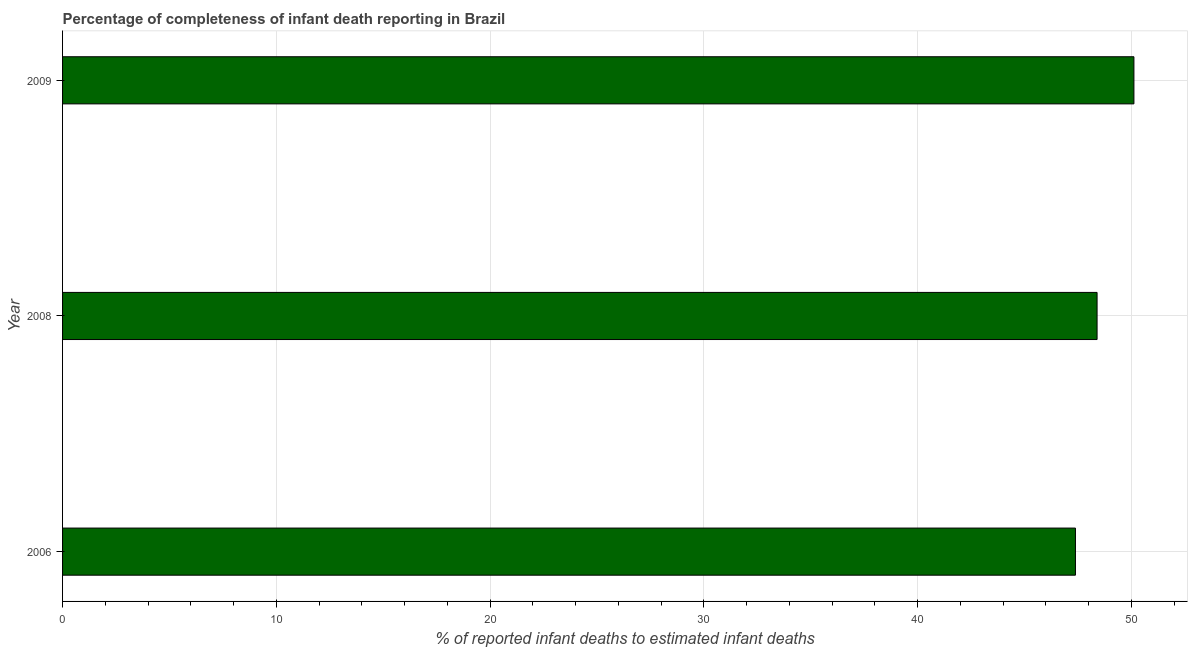What is the title of the graph?
Give a very brief answer. Percentage of completeness of infant death reporting in Brazil. What is the label or title of the X-axis?
Keep it short and to the point. % of reported infant deaths to estimated infant deaths. What is the label or title of the Y-axis?
Offer a very short reply. Year. What is the completeness of infant death reporting in 2009?
Keep it short and to the point. 50.12. Across all years, what is the maximum completeness of infant death reporting?
Provide a short and direct response. 50.12. Across all years, what is the minimum completeness of infant death reporting?
Your answer should be very brief. 47.38. What is the sum of the completeness of infant death reporting?
Make the answer very short. 145.89. What is the difference between the completeness of infant death reporting in 2008 and 2009?
Offer a terse response. -1.72. What is the average completeness of infant death reporting per year?
Offer a terse response. 48.63. What is the median completeness of infant death reporting?
Provide a succinct answer. 48.39. In how many years, is the completeness of infant death reporting greater than 16 %?
Ensure brevity in your answer.  3. Do a majority of the years between 2009 and 2006 (inclusive) have completeness of infant death reporting greater than 40 %?
Ensure brevity in your answer.  Yes. What is the ratio of the completeness of infant death reporting in 2008 to that in 2009?
Give a very brief answer. 0.97. Is the completeness of infant death reporting in 2006 less than that in 2009?
Make the answer very short. Yes. Is the difference between the completeness of infant death reporting in 2008 and 2009 greater than the difference between any two years?
Give a very brief answer. No. What is the difference between the highest and the second highest completeness of infant death reporting?
Provide a succinct answer. 1.72. What is the difference between the highest and the lowest completeness of infant death reporting?
Offer a very short reply. 2.74. In how many years, is the completeness of infant death reporting greater than the average completeness of infant death reporting taken over all years?
Your answer should be compact. 1. How many years are there in the graph?
Offer a very short reply. 3. What is the % of reported infant deaths to estimated infant deaths in 2006?
Give a very brief answer. 47.38. What is the % of reported infant deaths to estimated infant deaths in 2008?
Your answer should be very brief. 48.39. What is the % of reported infant deaths to estimated infant deaths of 2009?
Keep it short and to the point. 50.12. What is the difference between the % of reported infant deaths to estimated infant deaths in 2006 and 2008?
Keep it short and to the point. -1.01. What is the difference between the % of reported infant deaths to estimated infant deaths in 2006 and 2009?
Your answer should be very brief. -2.74. What is the difference between the % of reported infant deaths to estimated infant deaths in 2008 and 2009?
Your answer should be compact. -1.72. What is the ratio of the % of reported infant deaths to estimated infant deaths in 2006 to that in 2008?
Your answer should be very brief. 0.98. What is the ratio of the % of reported infant deaths to estimated infant deaths in 2006 to that in 2009?
Your answer should be compact. 0.94. What is the ratio of the % of reported infant deaths to estimated infant deaths in 2008 to that in 2009?
Provide a short and direct response. 0.97. 